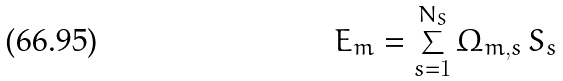Convert formula to latex. <formula><loc_0><loc_0><loc_500><loc_500>E _ { m } = \sum _ { s = 1 } ^ { N _ { S } } \Omega _ { m , s } \, S _ { s }</formula> 